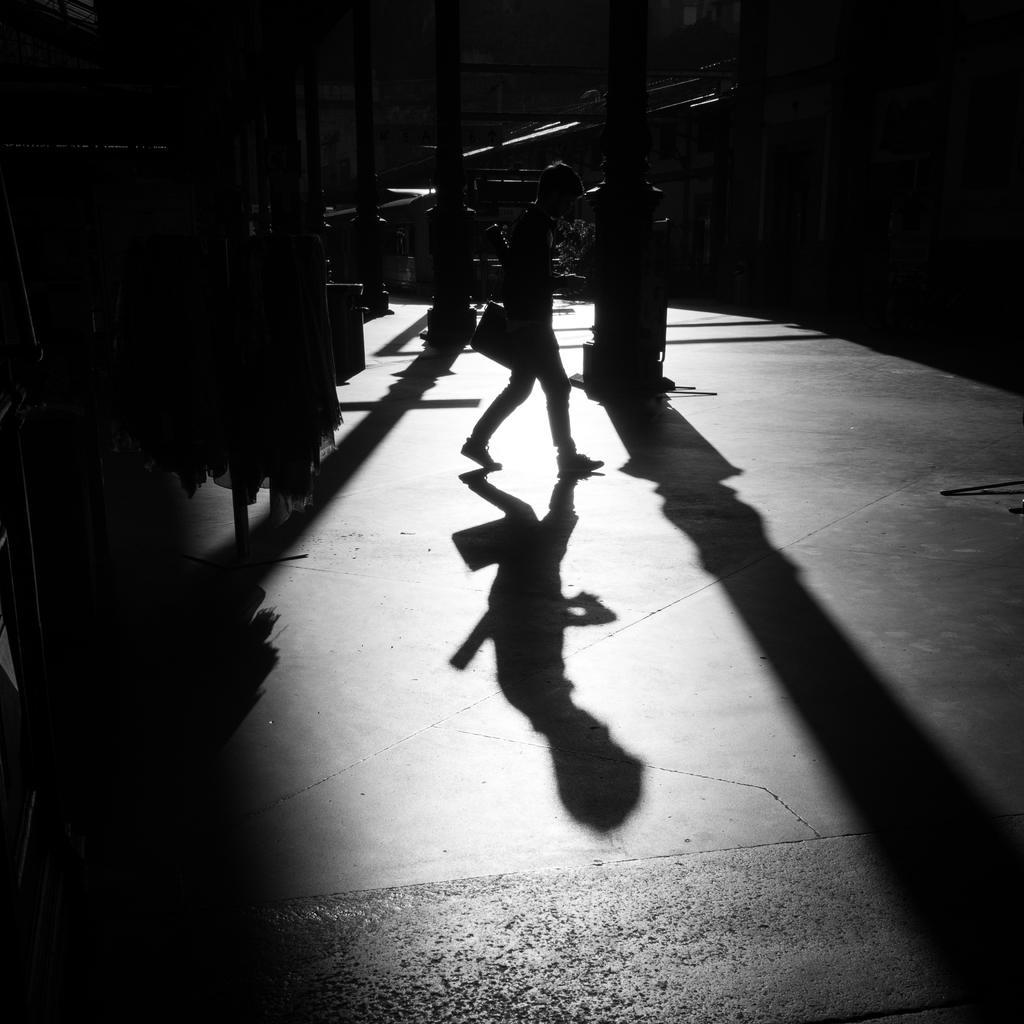In one or two sentences, can you explain what this image depicts? In this image one person is walking and his shadow is there on the floor. Behind some pillars are present. 